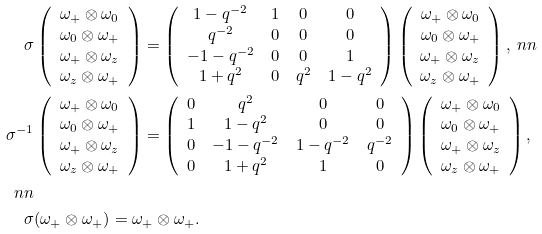Convert formula to latex. <formula><loc_0><loc_0><loc_500><loc_500>\sigma & \left ( \begin{array} { c } \omega _ { + } \otimes \omega _ { 0 } \\ \omega _ { 0 } \otimes \omega _ { + } \\ \omega _ { + } \otimes \omega _ { z } \\ \omega _ { z } \otimes \omega _ { + } \end{array} \right ) = \left ( \begin{array} { c c c c } 1 - q ^ { - 2 } & 1 & 0 & 0 \\ q ^ { - 2 } & 0 & 0 & 0 \\ - 1 - q ^ { - 2 } & 0 & 0 & 1 \\ 1 + q ^ { 2 } & 0 & q ^ { 2 } & 1 - q ^ { 2 } \end{array} \right ) \left ( \begin{array} { c } \omega _ { + } \otimes \omega _ { 0 } \\ \omega _ { 0 } \otimes \omega _ { + } \\ \omega _ { + } \otimes \omega _ { z } \\ \omega _ { z } \otimes \omega _ { + } \end{array} \right ) , \ n n \\ \sigma ^ { - 1 } & \left ( \begin{array} { c } \omega _ { + } \otimes \omega _ { 0 } \\ \omega _ { 0 } \otimes \omega _ { + } \\ \omega _ { + } \otimes \omega _ { z } \\ \omega _ { z } \otimes \omega _ { + } \end{array} \right ) = \left ( \begin{array} { c c c c } 0 & q ^ { 2 } & 0 & 0 \\ 1 & 1 - q ^ { 2 } & 0 & 0 \\ 0 & - 1 - q ^ { - 2 } & 1 - q ^ { - 2 } & q ^ { - 2 } \\ 0 & 1 + q ^ { 2 } & 1 & 0 \end{array} \right ) \left ( \begin{array} { c } \omega _ { + } \otimes \omega _ { 0 } \\ \omega _ { 0 } \otimes \omega _ { + } \\ \omega _ { + } \otimes \omega _ { z } \\ \omega _ { z } \otimes \omega _ { + } \end{array} \right ) , \\ \ n n \\ \sigma & ( \omega _ { + } \otimes \omega _ { + } ) = \omega _ { + } \otimes \omega _ { + } .</formula> 